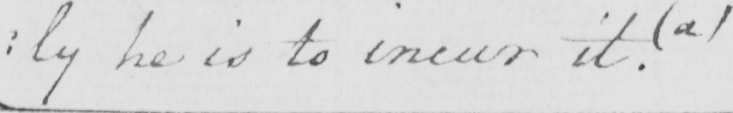What text is written in this handwritten line? : ly he is to incur it . ( a ) 